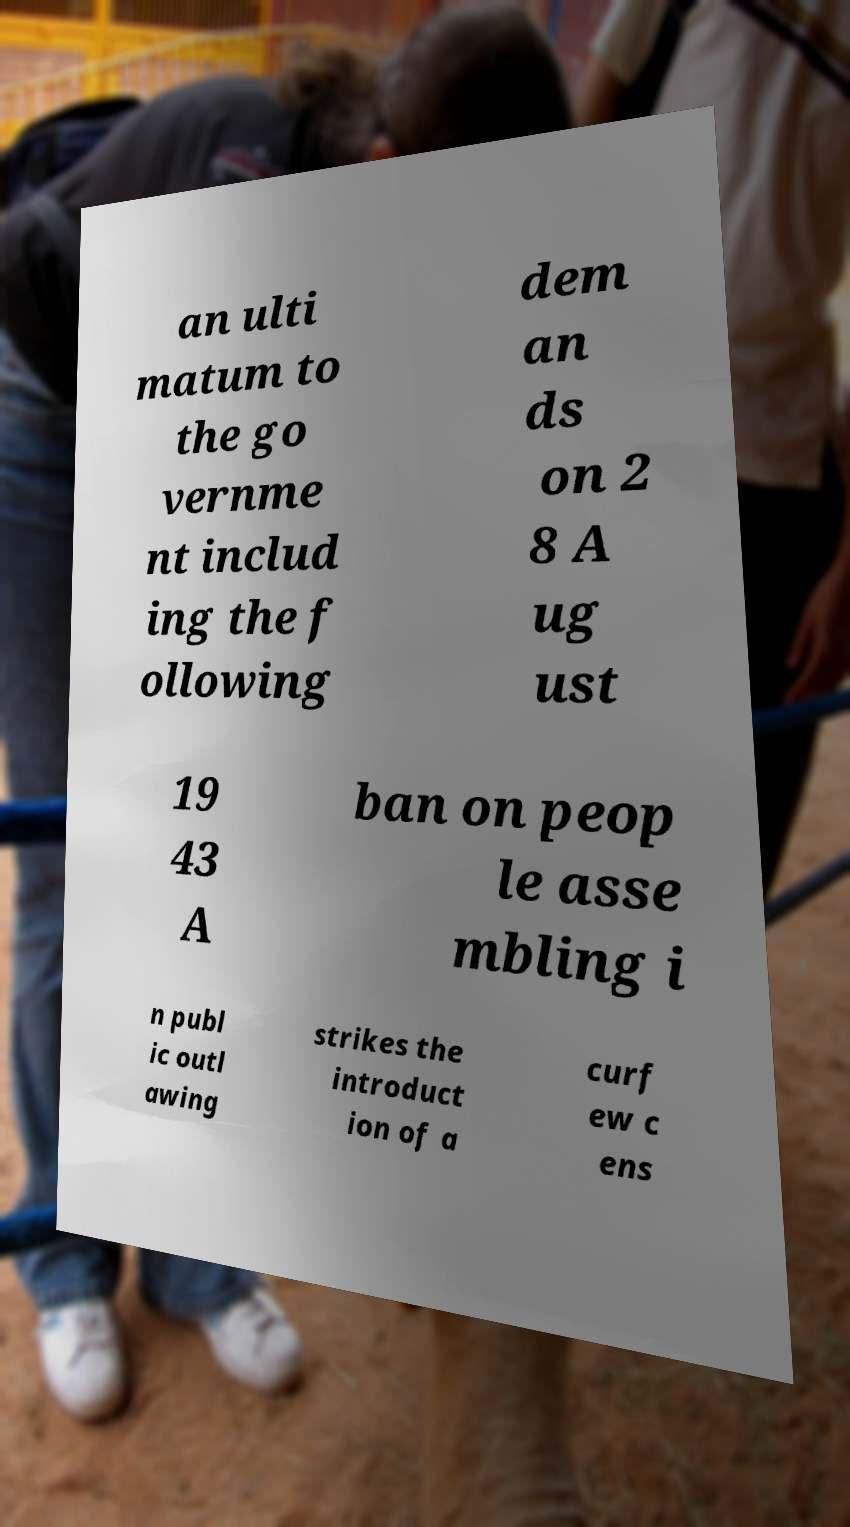Can you accurately transcribe the text from the provided image for me? an ulti matum to the go vernme nt includ ing the f ollowing dem an ds on 2 8 A ug ust 19 43 A ban on peop le asse mbling i n publ ic outl awing strikes the introduct ion of a curf ew c ens 